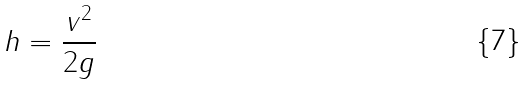<formula> <loc_0><loc_0><loc_500><loc_500>h = \frac { v ^ { 2 } } { 2 g }</formula> 